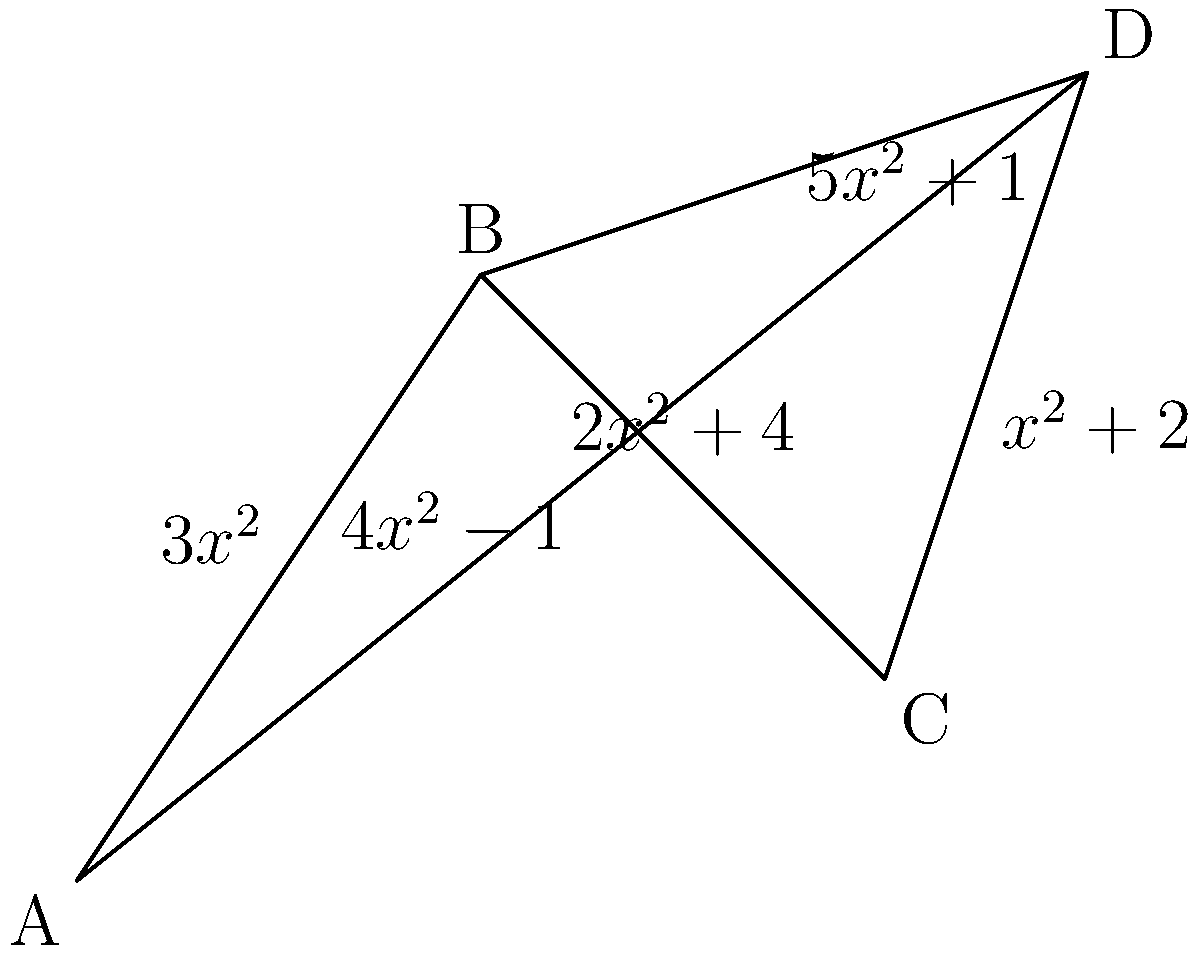As a supply chain manager, you need to optimize the transportation costs between four distribution centers (A, B, C, and D) represented in the network graph. The cost of transportation between centers is a function of distance $x$ (in hundreds of miles). Find the optimal distance $x$ that minimizes the total transportation cost for a round trip from A to B to C to D and back to A, including the shortcut from B to D. To solve this problem, we'll follow these steps:

1) First, let's define the total cost function. The round trip cost is the sum of all edge costs:

   $C(x) = (3x^2) + (2x^2+4) + (x^2+2) + (4x^2-1) + (5x^2+1)$

2) Simplify the cost function:

   $C(x) = 3x^2 + 2x^2 + x^2 + 4x^2 + 5x^2 + 4 + 2 - 1 + 1$
   $C(x) = 15x^2 + 6$

3) To find the minimum cost, we need to find where the derivative of $C(x)$ equals zero:

   $C'(x) = 30x$

4) Set $C'(x) = 0$ and solve for $x$:

   $30x = 0$
   $x = 0$

5) To confirm this is a minimum (not a maximum), check the second derivative:

   $C''(x) = 30$

   Since $C''(x)$ is positive, $x = 0$ gives a minimum.

6) However, $x = 0$ is not a practical solution as it implies zero distance. In real-world applications, we would need to consider the minimum possible distance between centers. The function shows that as $x$ increases, the cost increases quadratically. Therefore, the optimal practical solution is to choose the minimum possible distance that satisfies other constraints (e.g., physical limitations, delivery time requirements).
Answer: Theoretical minimum: $x = 0$. Practical solution: Minimum possible distance satisfying other constraints. 